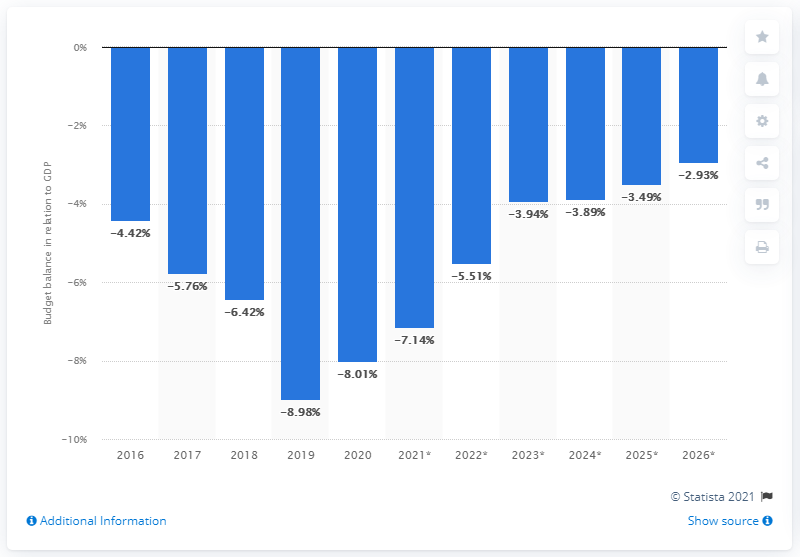Highlight a few significant elements in this photo. The budget balance of Pakistan has been shown in relation to GDP from 2016 to 2020. 